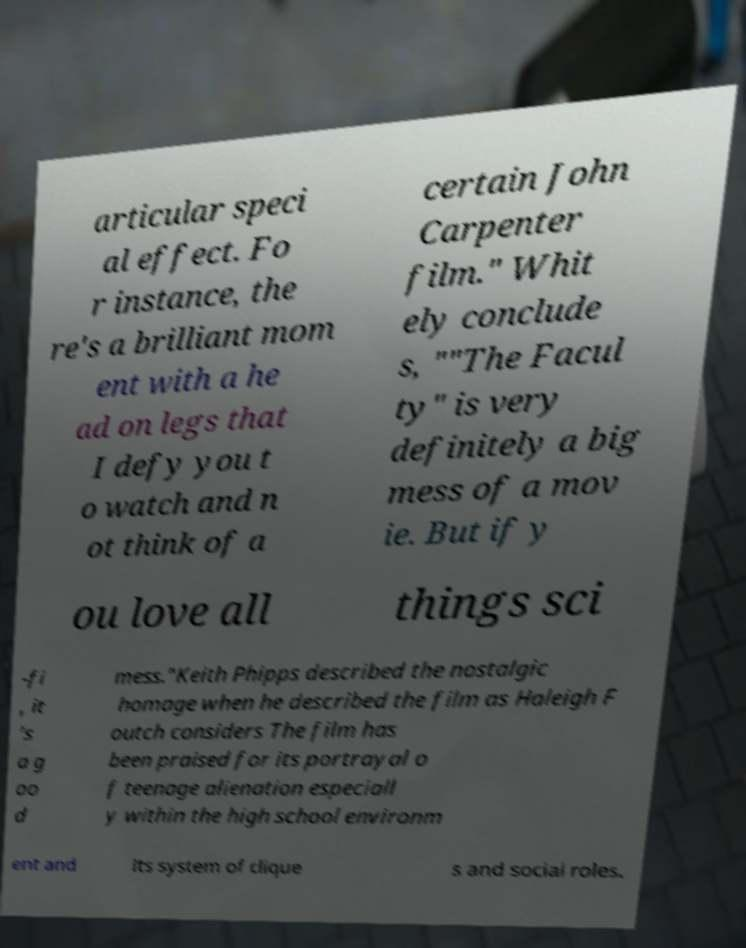Please identify and transcribe the text found in this image. articular speci al effect. Fo r instance, the re's a brilliant mom ent with a he ad on legs that I defy you t o watch and n ot think of a certain John Carpenter film." Whit ely conclude s, ""The Facul ty" is very definitely a big mess of a mov ie. But if y ou love all things sci -fi , it ’s a g oo d mess."Keith Phipps described the nostalgic homage when he described the film as Haleigh F outch considers The film has been praised for its portrayal o f teenage alienation especiall y within the high school environm ent and its system of clique s and social roles. 